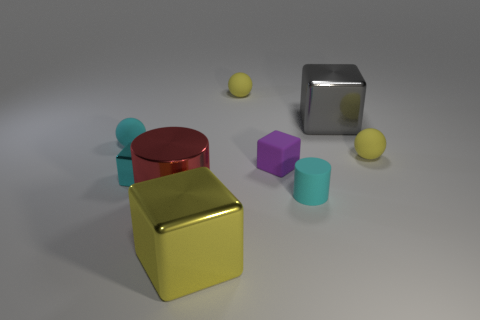Add 1 large yellow cubes. How many objects exist? 10 Subtract all cubes. How many objects are left? 5 Subtract all yellow spheres. Subtract all red metallic things. How many objects are left? 6 Add 6 cyan cubes. How many cyan cubes are left? 7 Add 3 tiny purple blocks. How many tiny purple blocks exist? 4 Subtract 1 yellow cubes. How many objects are left? 8 